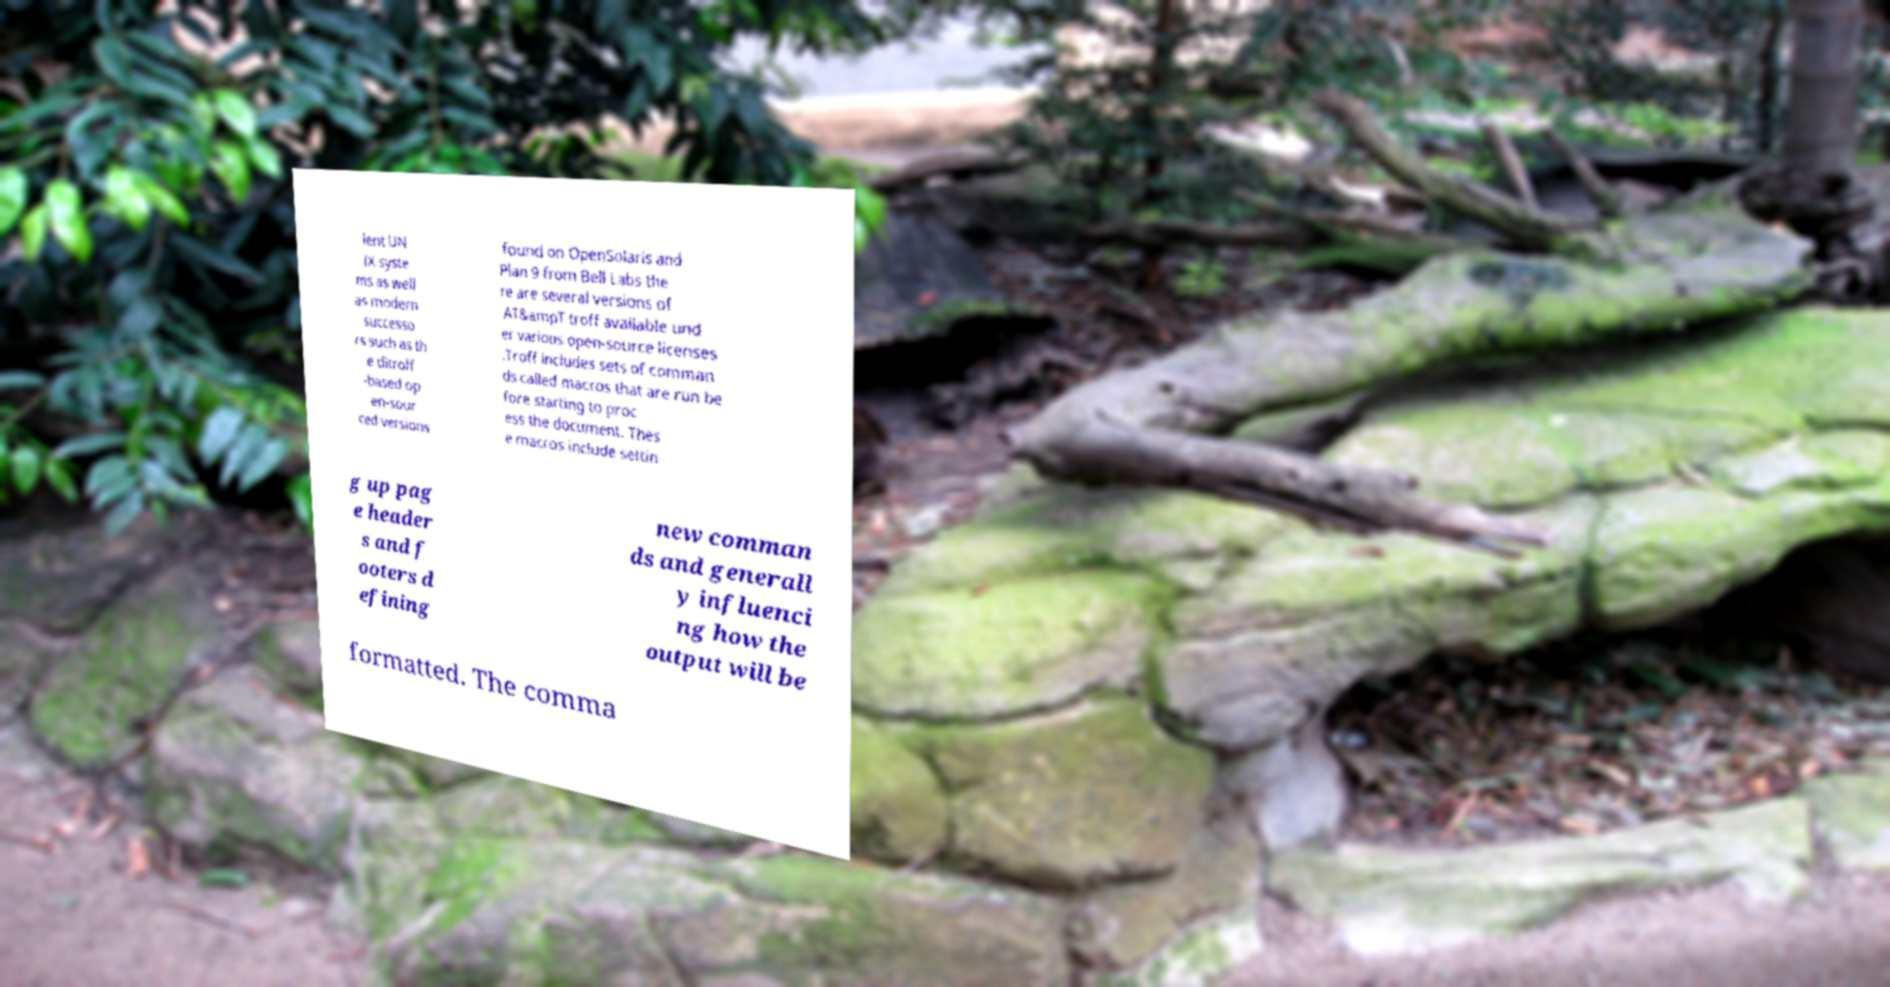Please read and relay the text visible in this image. What does it say? ient UN IX syste ms as well as modern successo rs such as th e ditroff -based op en-sour ced versions found on OpenSolaris and Plan 9 from Bell Labs the re are several versions of AT&ampT troff available und er various open-source licenses .Troff includes sets of comman ds called macros that are run be fore starting to proc ess the document. Thes e macros include settin g up pag e header s and f ooters d efining new comman ds and generall y influenci ng how the output will be formatted. The comma 